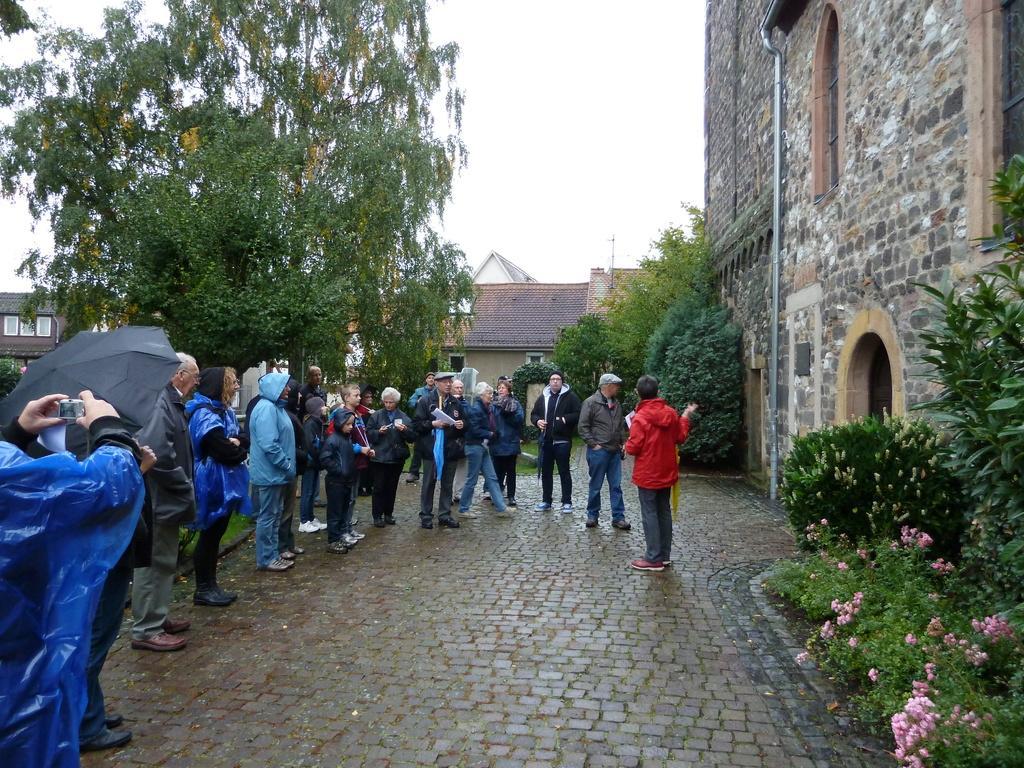Please provide a concise description of this image. In this image I can see a group of people are standing among them some are holding objects in hands. Here I can see an umbrella which is black in color. In the background I can see buildings, trees, flower plants, and the sky. 